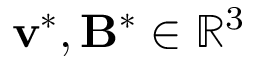Convert formula to latex. <formula><loc_0><loc_0><loc_500><loc_500>v ^ { * } , B ^ { * } \in \mathbb { R } ^ { 3 }</formula> 